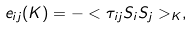<formula> <loc_0><loc_0><loc_500><loc_500>e _ { i j } ( K ) = - < \tau _ { i j } S _ { i } S _ { j } > _ { K } ,</formula> 